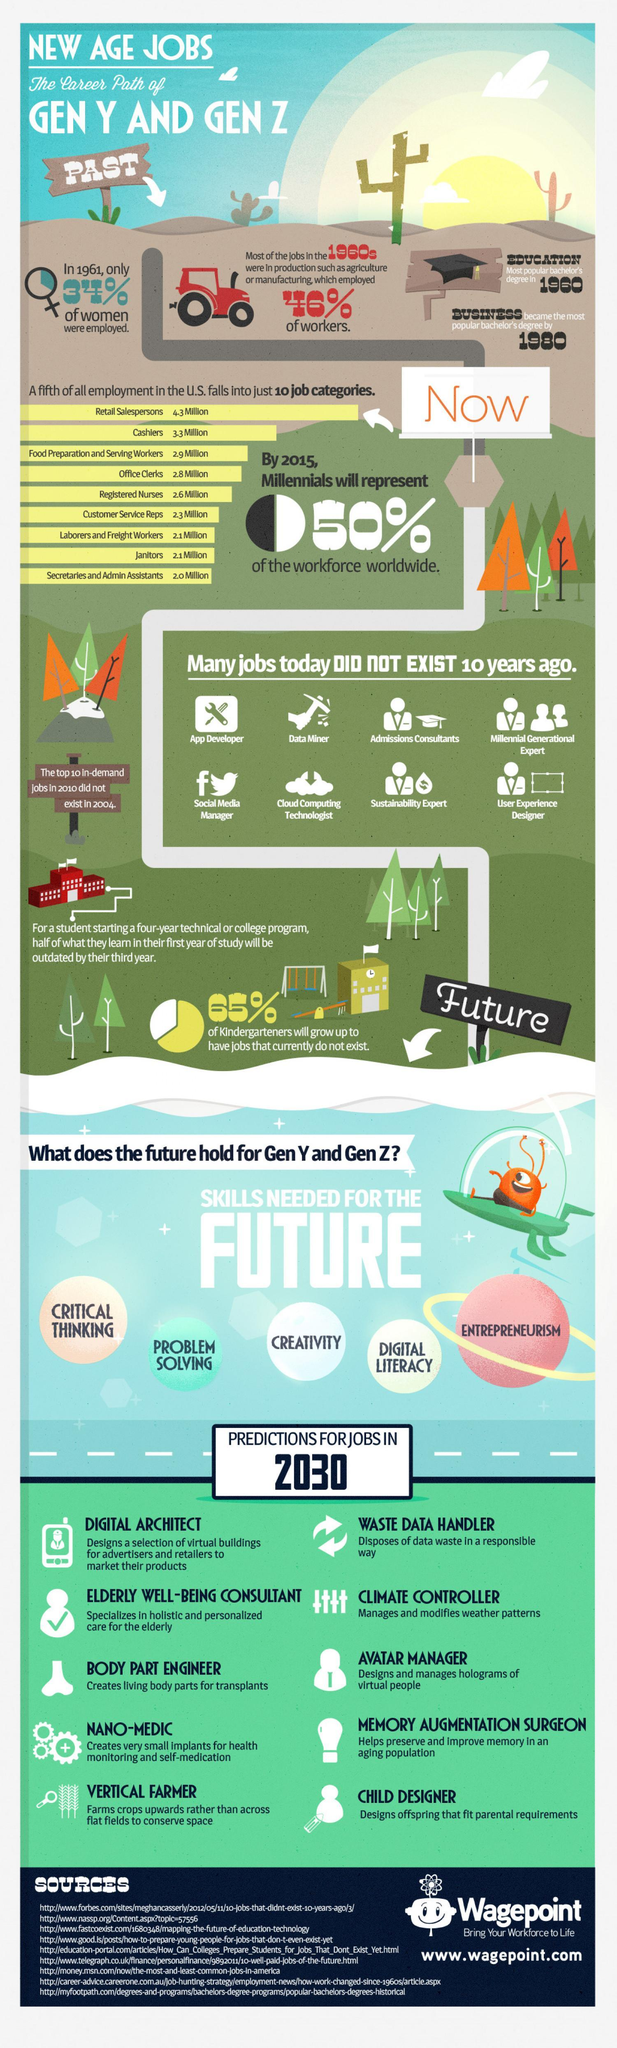The jobs in 1960s were in which sectors mainly?
Answer the question with a short phrase. agriculture or manufacturing Which of the present job categories in US has the second highest number of people? Cashiers What is the job title of someone who deals with platforms like Facebook, Twitter etc? Social media manager What is listed fifth in the skills needed for future? Entrepreneurism What is the probable job title for someone who designs holograms of virtual people? Avatar manager In which year only 34% of women were employed? 1961 Half of the workforce will be comprised of which generation group in 2015? millennials Which was the most desired bachelors degree in 1980? business which bachelor's degree was most sought-after in 1960? education 